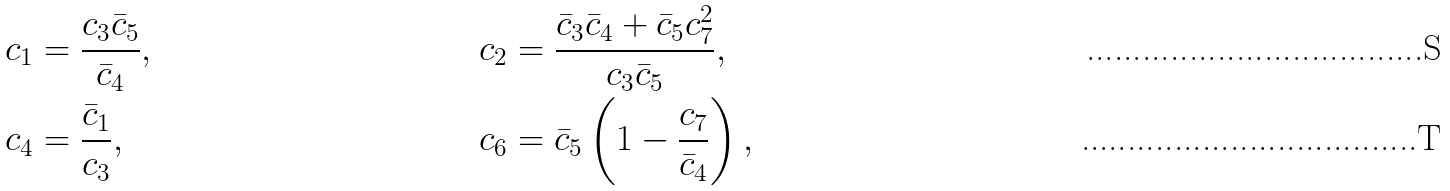Convert formula to latex. <formula><loc_0><loc_0><loc_500><loc_500>c _ { 1 } & = \frac { c _ { 3 } \bar { c } _ { 5 } } { \bar { c } _ { 4 } } , & c _ { 2 } & = \frac { \bar { c } _ { 3 } \bar { c } _ { 4 } + \bar { c } _ { 5 } c _ { 7 } ^ { 2 } } { c _ { 3 } \bar { c } _ { 5 } } , \\ c _ { 4 } & = \frac { \bar { c } _ { 1 } } { c _ { 3 } } , & c _ { 6 } & = \bar { c } _ { 5 } \left ( 1 - \frac { c _ { 7 } } { \bar { c } _ { 4 } } \right ) ,</formula> 